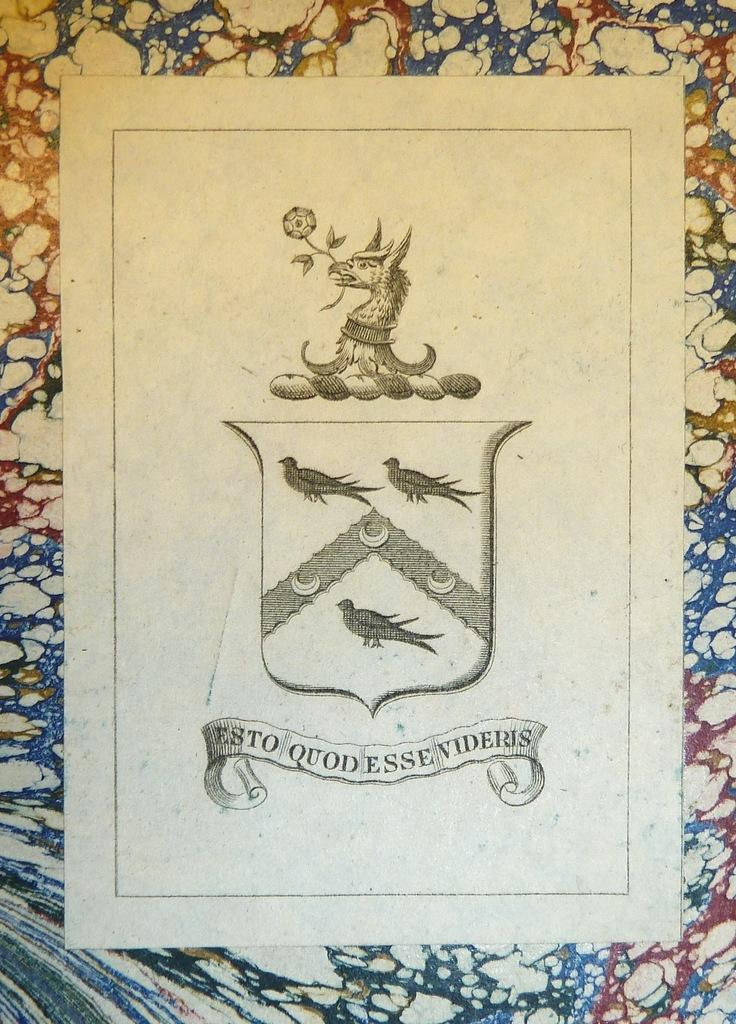What type of animals are depicted in the images in the picture? There are pictures of birds in the image. What else can be seen in the image besides the pictures of birds? There is text in the image. How would you describe the background of the image? The background of the image is multi-colored. What time of day is it in the image? The time of day is not mentioned or depicted in the image, so it cannot be determined. 